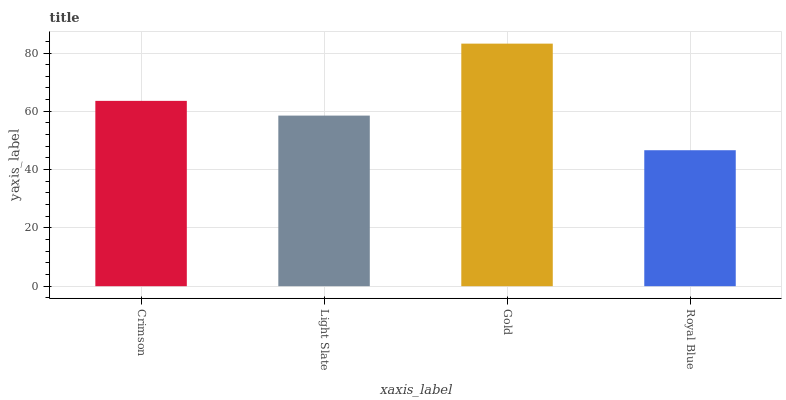Is Royal Blue the minimum?
Answer yes or no. Yes. Is Gold the maximum?
Answer yes or no. Yes. Is Light Slate the minimum?
Answer yes or no. No. Is Light Slate the maximum?
Answer yes or no. No. Is Crimson greater than Light Slate?
Answer yes or no. Yes. Is Light Slate less than Crimson?
Answer yes or no. Yes. Is Light Slate greater than Crimson?
Answer yes or no. No. Is Crimson less than Light Slate?
Answer yes or no. No. Is Crimson the high median?
Answer yes or no. Yes. Is Light Slate the low median?
Answer yes or no. Yes. Is Gold the high median?
Answer yes or no. No. Is Royal Blue the low median?
Answer yes or no. No. 